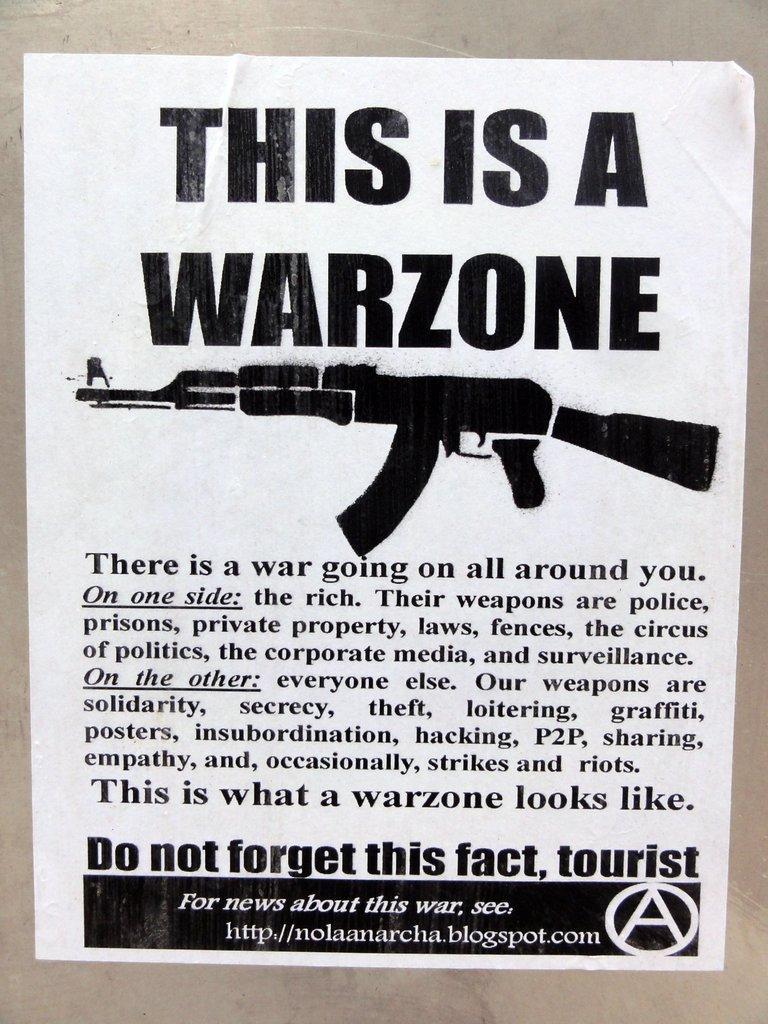How would you summarize this image in a sentence or two? In this image we can able to see a pamphlet and on that pamphlet we can able to see a gun picture over here, and we can see a website link here, and there is a sentence written on it, and there are words called this is a war zone over here and we can able to see a letter A in a circle. 